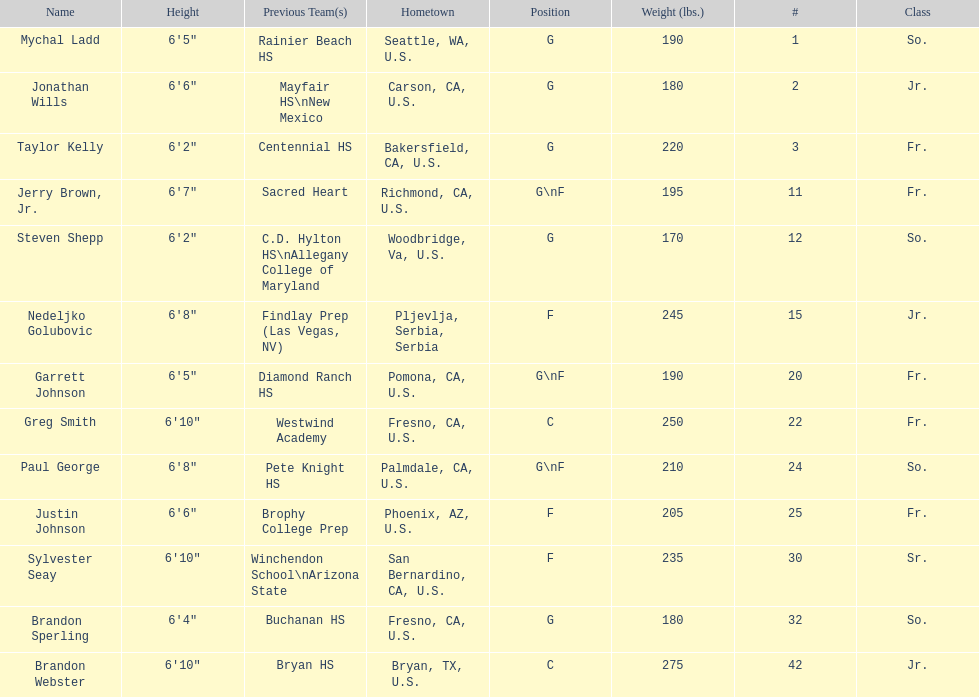Taylor kelly is shorter than 6' 3", which other player is also shorter than 6' 3"? Steven Shepp. 